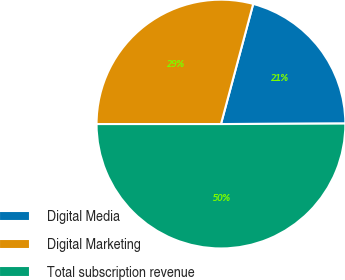Convert chart to OTSL. <chart><loc_0><loc_0><loc_500><loc_500><pie_chart><fcel>Digital Media<fcel>Digital Marketing<fcel>Total subscription revenue<nl><fcel>20.76%<fcel>29.17%<fcel>50.06%<nl></chart> 